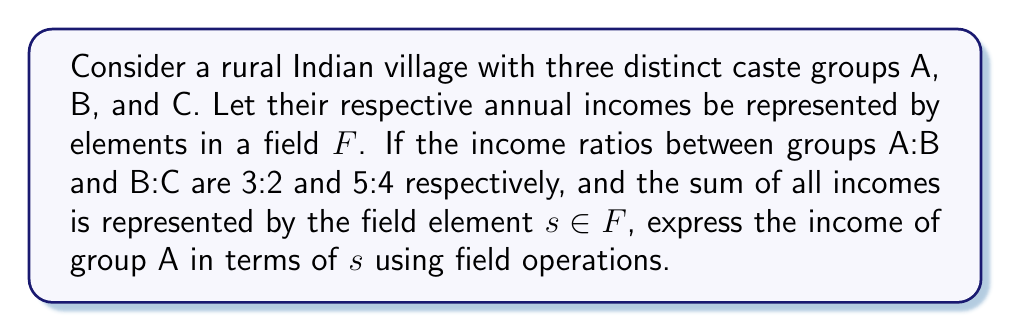Give your solution to this math problem. 1) Let the incomes of groups A, B, and C be represented by field elements $a$, $b$, and $c$ respectively.

2) Given the income ratios, we can write:
   $\frac{a}{b} = \frac{3}{2}$ and $\frac{b}{c} = \frac{5}{4}$

3) From these ratios, we can express $b$ and $c$ in terms of $a$:
   $b = \frac{2a}{3}$ and $c = \frac{8a}{15}$

4) The sum of all incomes is given by $s$, so:
   $a + b + c = s$

5) Substituting the expressions for $b$ and $c$:
   $a + \frac{2a}{3} + \frac{8a}{15} = s$

6) Finding a common denominator:
   $\frac{15a}{15} + \frac{10a}{15} + \frac{8a}{15} = s$

7) Simplifying:
   $\frac{33a}{15} = s$

8) Multiplying both sides by 15 (field multiplication):
   $33a = 15s$

9) Multiplying both sides by the multiplicative inverse of 33 in the field:
   $a = \frac{15s}{33}$

Therefore, the income of group A can be expressed as $\frac{15s}{33}$ in terms of the total income $s$.
Answer: $a = \frac{15s}{33}$ 